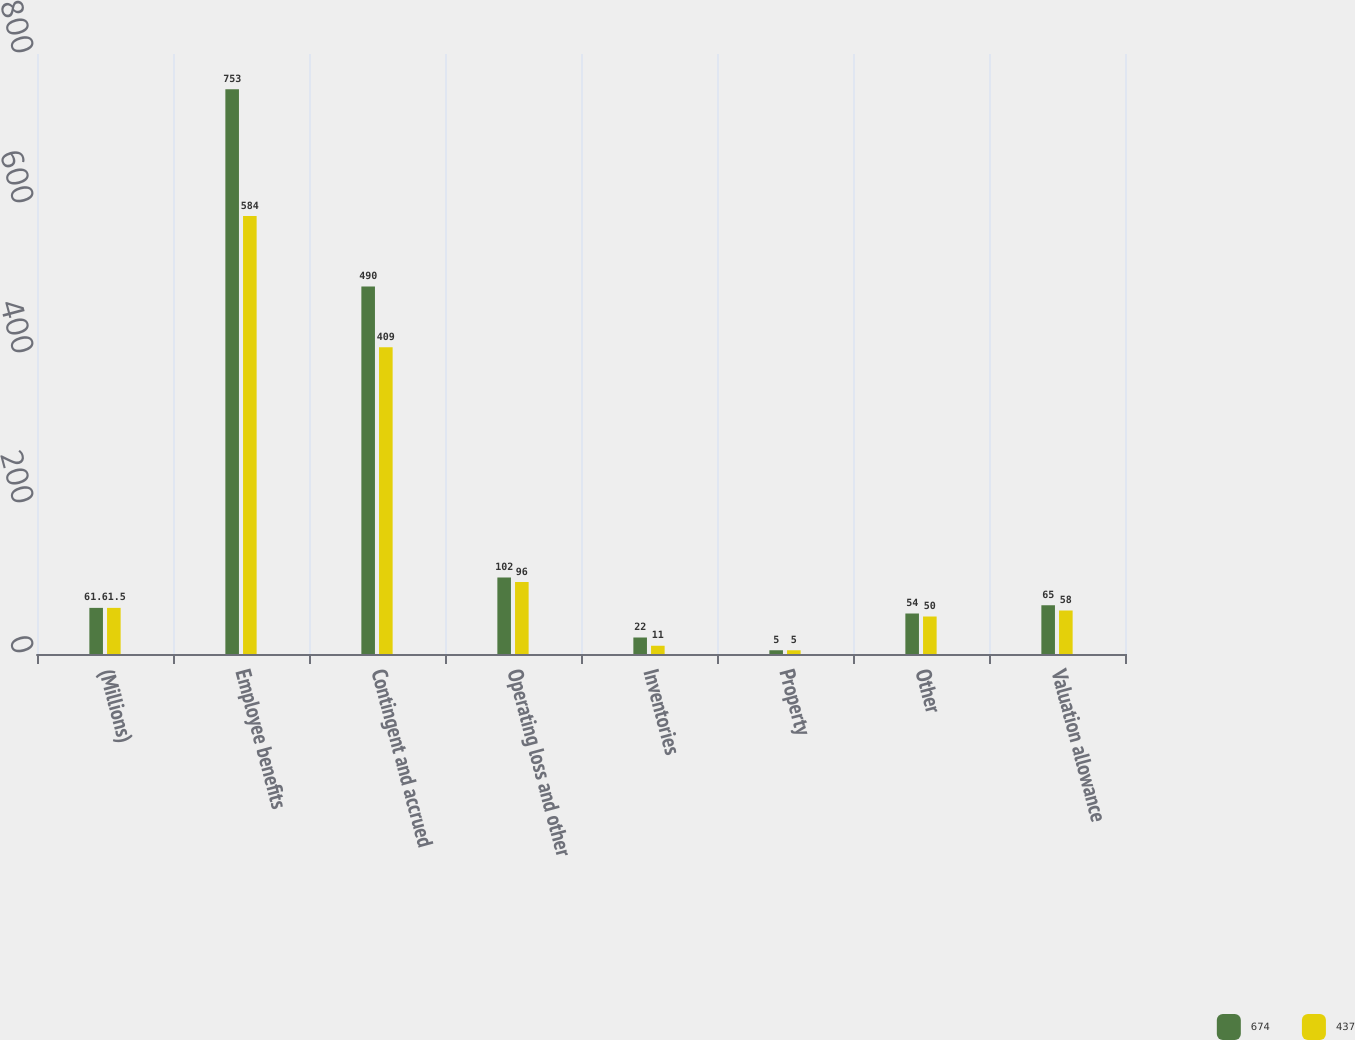Convert chart to OTSL. <chart><loc_0><loc_0><loc_500><loc_500><stacked_bar_chart><ecel><fcel>(Millions)<fcel>Employee benefits<fcel>Contingent and accrued<fcel>Operating loss and other<fcel>Inventories<fcel>Property<fcel>Other<fcel>Valuation allowance<nl><fcel>674<fcel>61.5<fcel>753<fcel>490<fcel>102<fcel>22<fcel>5<fcel>54<fcel>65<nl><fcel>437<fcel>61.5<fcel>584<fcel>409<fcel>96<fcel>11<fcel>5<fcel>50<fcel>58<nl></chart> 